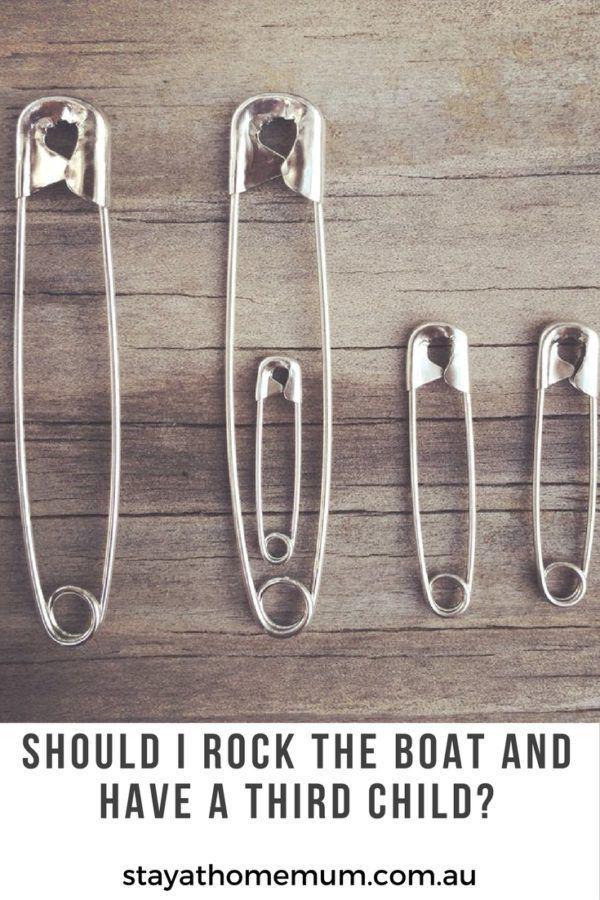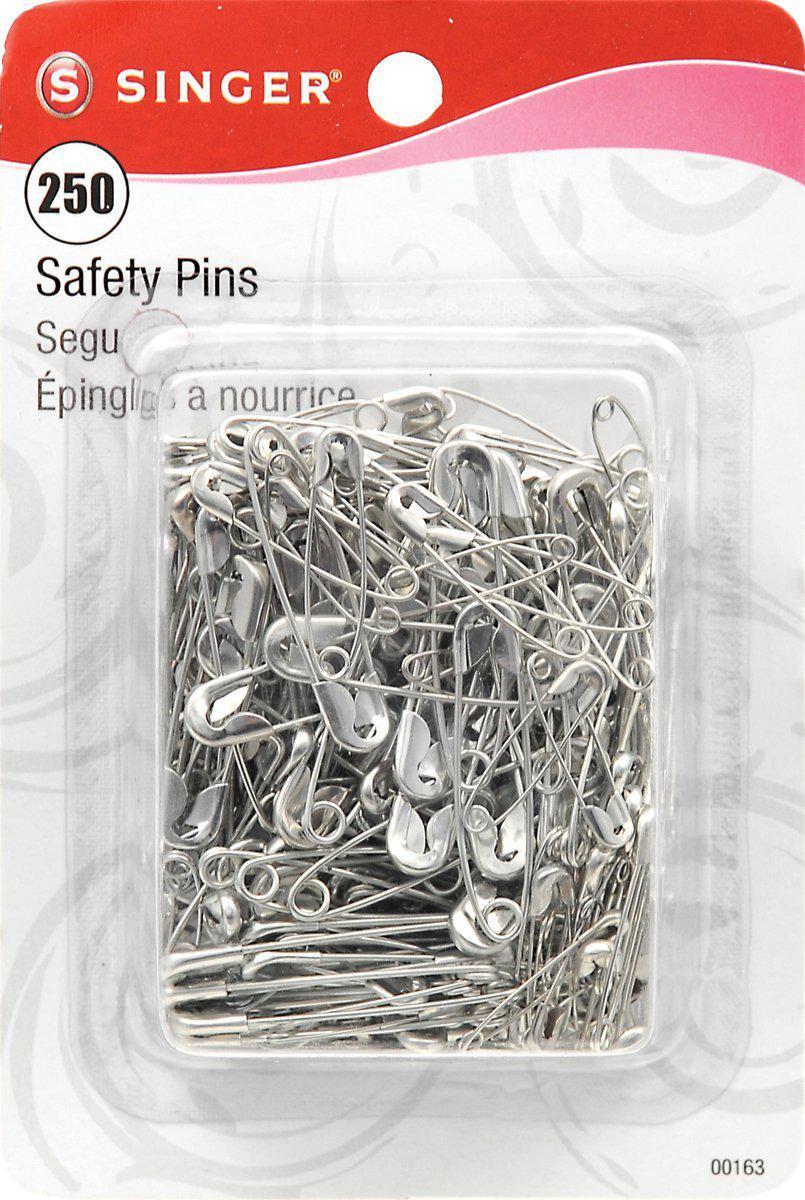The first image is the image on the left, the second image is the image on the right. Assess this claim about the two images: "The left image shows safety pins arranged in a kind of checkerboard pattern, and the right image includes at least one vertical safety pin depiction.". Correct or not? Answer yes or no. No. 